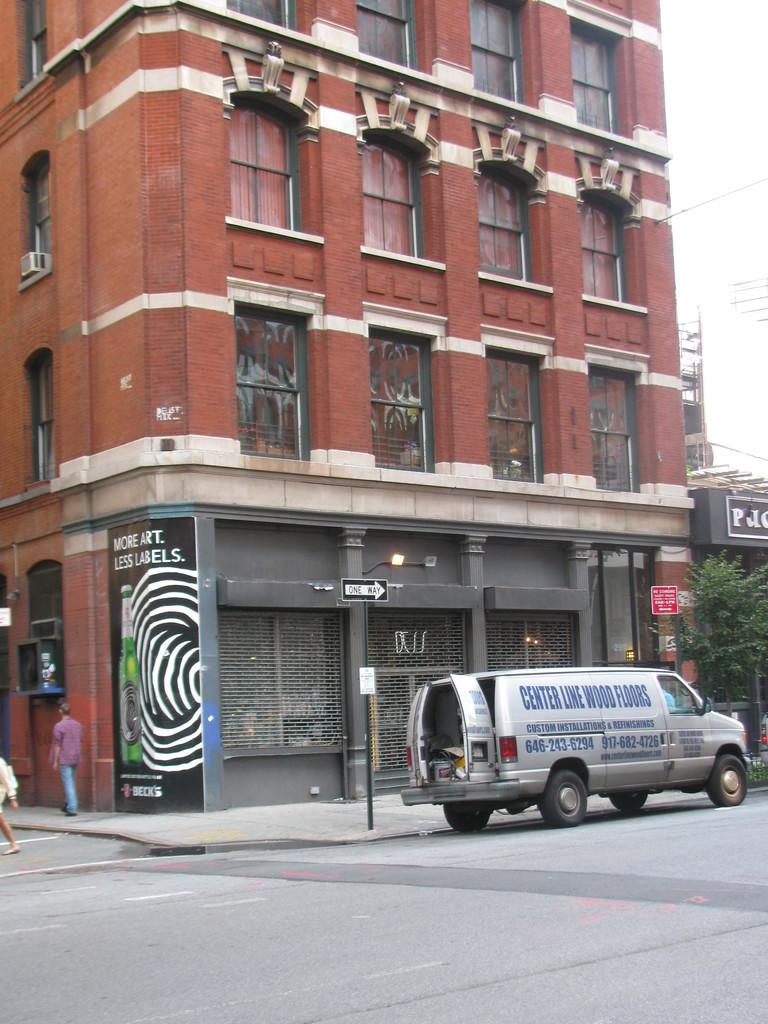<image>
Provide a brief description of the given image. van with center line wood floors printed on side in front of brick building 